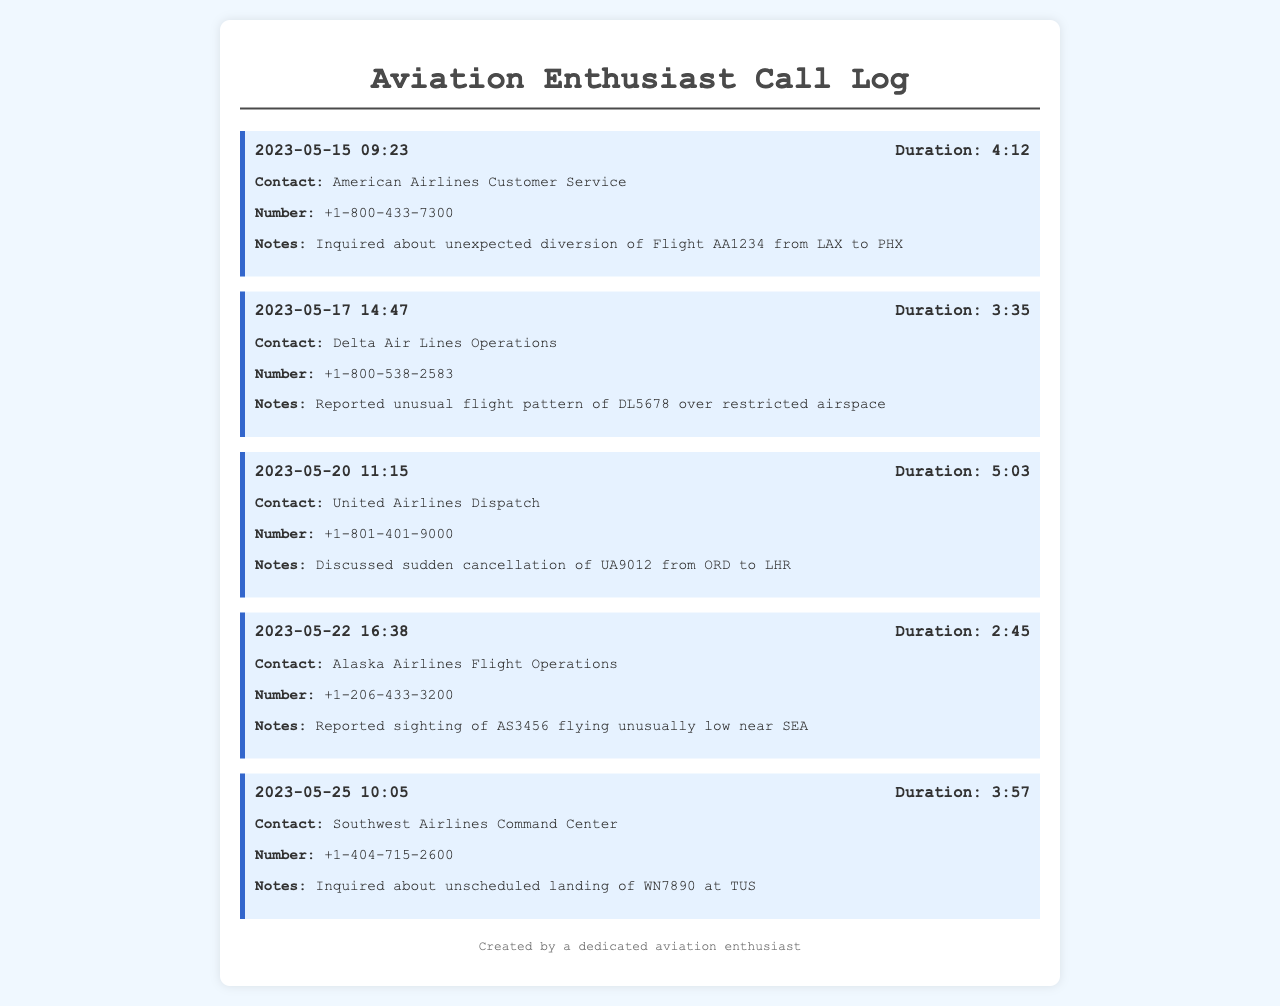What is the date of the call to American Airlines? The date of the call to American Airlines is listed as May 15, 2023.
Answer: 2023-05-15 What was the duration of the call to Delta Air Lines? The duration of the call to Delta Air Lines is shown to be 3 minutes and 35 seconds.
Answer: 3:35 What flight was discussed during the call to United Airlines? The flight discussed during the call to United Airlines was UA9012.
Answer: UA9012 What unusual flight pattern was reported to Delta Air Lines? The unusual flight pattern reported to Delta Air Lines was over restricted airspace.
Answer: over restricted airspace What was the purpose of the call to Alaska Airlines? The purpose of the call to Alaska Airlines was to report a sighting of AS3456 flying unusually low.
Answer: sighting of AS3456 flying unusually low Which airline was contacted regarding an unscheduled landing? The airline contacted regarding an unscheduled landing was Southwest Airlines.
Answer: Southwest Airlines How many calls were made in total? The total number of calls made is equal to the number of call entries listed in the document.
Answer: 5 What is the phone number for American Airlines Customer Service? The phone number for American Airlines Customer Service is provided in the document.
Answer: +1-800-433-7300 Which flight was reported canceled from ORD to LHR? The flight reported canceled from ORD to LHR was UA9012.
Answer: UA9012 